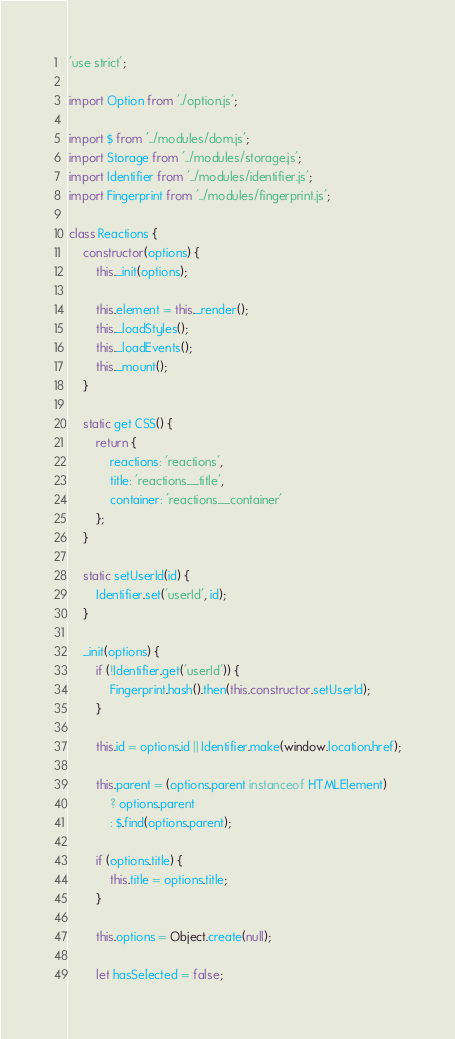Convert code to text. <code><loc_0><loc_0><loc_500><loc_500><_JavaScript_>'use strict';

import Option from './option.js';

import $ from '../modules/dom.js';
import Storage from '../modules/storage.js';
import Identifier from '../modules/identifier.js';
import Fingerprint from '../modules/fingerprint.js';

class Reactions {
    constructor(options) {
        this._init(options);

        this.element = this._render();
        this._loadStyles();
        this._loadEvents();
        this._mount();
    }

    static get CSS() {
        return {
            reactions: 'reactions',
            title: 'reactions__title',
            container: 'reactions__container'
        };
    }

    static setUserId(id) {
        Identifier.set('userId', id);
    }

    _init(options) {
        if (!Identifier.get('userId')) {
            Fingerprint.hash().then(this.constructor.setUserId);
        }

        this.id = options.id || Identifier.make(window.location.href);

        this.parent = (options.parent instanceof HTMLElement)
            ? options.parent
            : $.find(options.parent);

        if (options.title) {
            this.title = options.title;
        }

        this.options = Object.create(null);

        let hasSelected = false;
</code> 